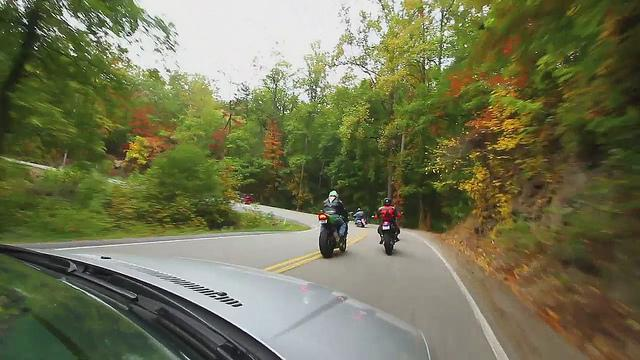How many motorcycles are on the highway apparently ahead of the vehicle driving?

Choices:
A) four
B) six
C) two
D) three three 